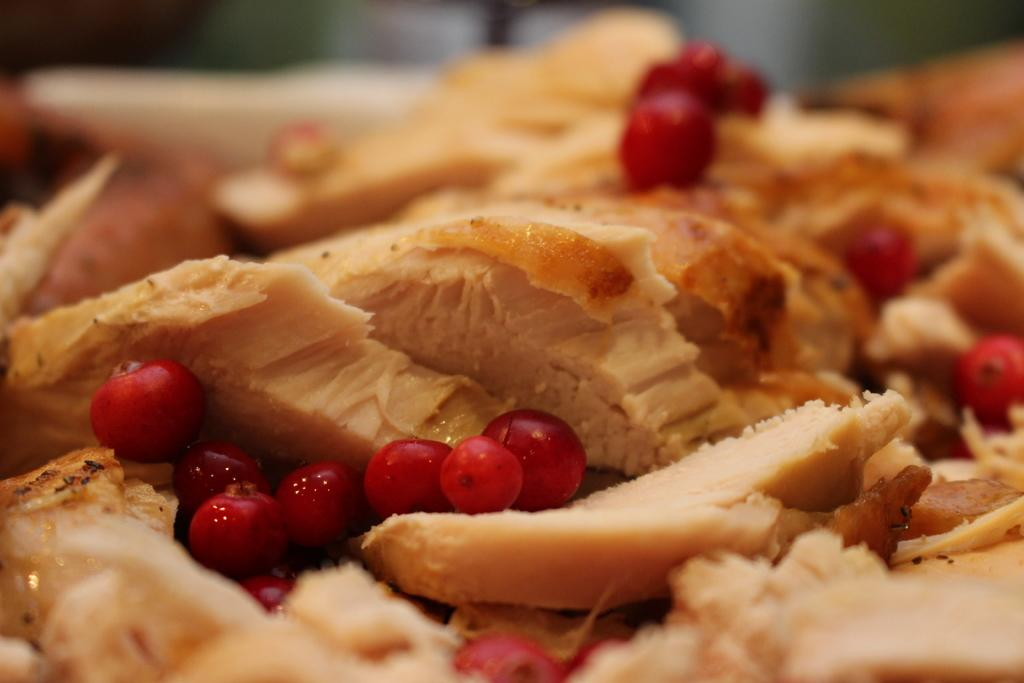What type of food can be seen in the image? There is food in the image, with cream and brown colors. What additional detail can be observed about the food? There are red cherries in the image. How would you describe the background of the image? The background of the image is blurred. Where can the pin be found in the image? There is no pin present in the image. What type of nut is used as a topping for the food in the image? There is no nut present in the image. 